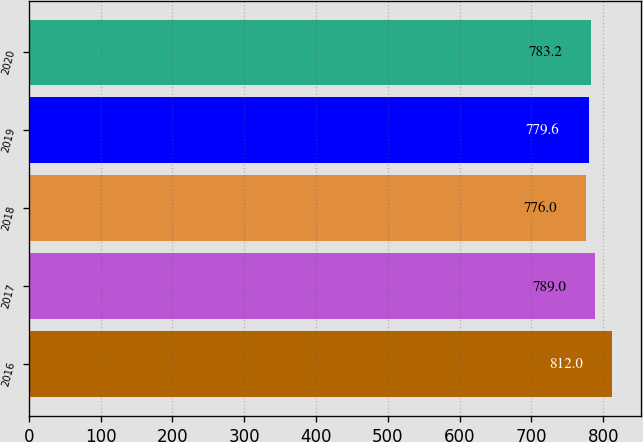Convert chart to OTSL. <chart><loc_0><loc_0><loc_500><loc_500><bar_chart><fcel>2016<fcel>2017<fcel>2018<fcel>2019<fcel>2020<nl><fcel>812<fcel>789<fcel>776<fcel>779.6<fcel>783.2<nl></chart> 